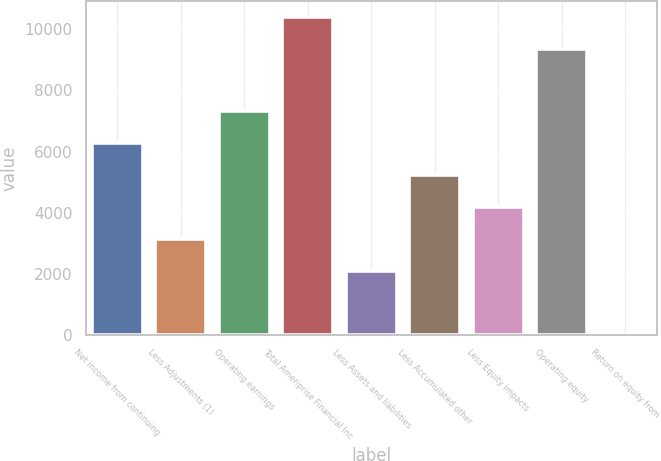Convert chart. <chart><loc_0><loc_0><loc_500><loc_500><bar_chart><fcel>Net income from continuing<fcel>Less Adjustments (1)<fcel>Operating earnings<fcel>Total Ameriprise Financial Inc<fcel>Less Assets and liabilities<fcel>Less Accumulated other<fcel>Less Equity impacts<fcel>Operating equity<fcel>Return on equity from<nl><fcel>6286.6<fcel>3149.05<fcel>7332.45<fcel>10405.9<fcel>2103.2<fcel>5240.75<fcel>4194.9<fcel>9360<fcel>11.5<nl></chart> 